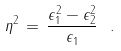<formula> <loc_0><loc_0><loc_500><loc_500>\eta ^ { 2 } \, = \, \frac { \epsilon _ { 1 } ^ { 2 } - \epsilon _ { 2 } ^ { 2 } } { \epsilon _ { 1 } } \ .</formula> 